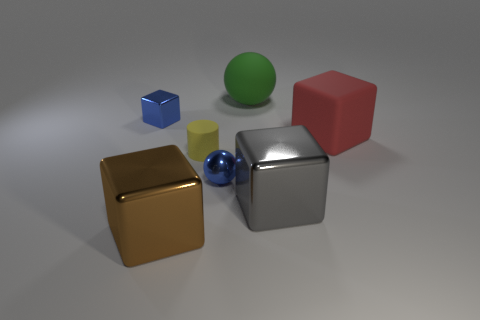Subtract all small blue metal blocks. How many blocks are left? 3 Add 2 objects. How many objects exist? 9 Subtract all green spheres. How many spheres are left? 1 Add 6 rubber spheres. How many rubber spheres are left? 7 Add 3 large green rubber things. How many large green rubber things exist? 4 Subtract 1 yellow cylinders. How many objects are left? 6 Subtract all cylinders. How many objects are left? 6 Subtract 2 spheres. How many spheres are left? 0 Subtract all red blocks. Subtract all gray cylinders. How many blocks are left? 3 Subtract all gray cylinders. How many green spheres are left? 1 